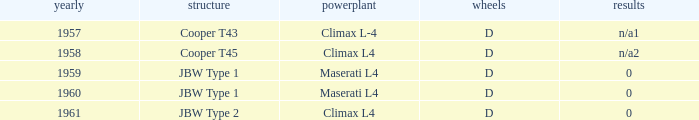What engine was in the year of 1961? Climax L4. 